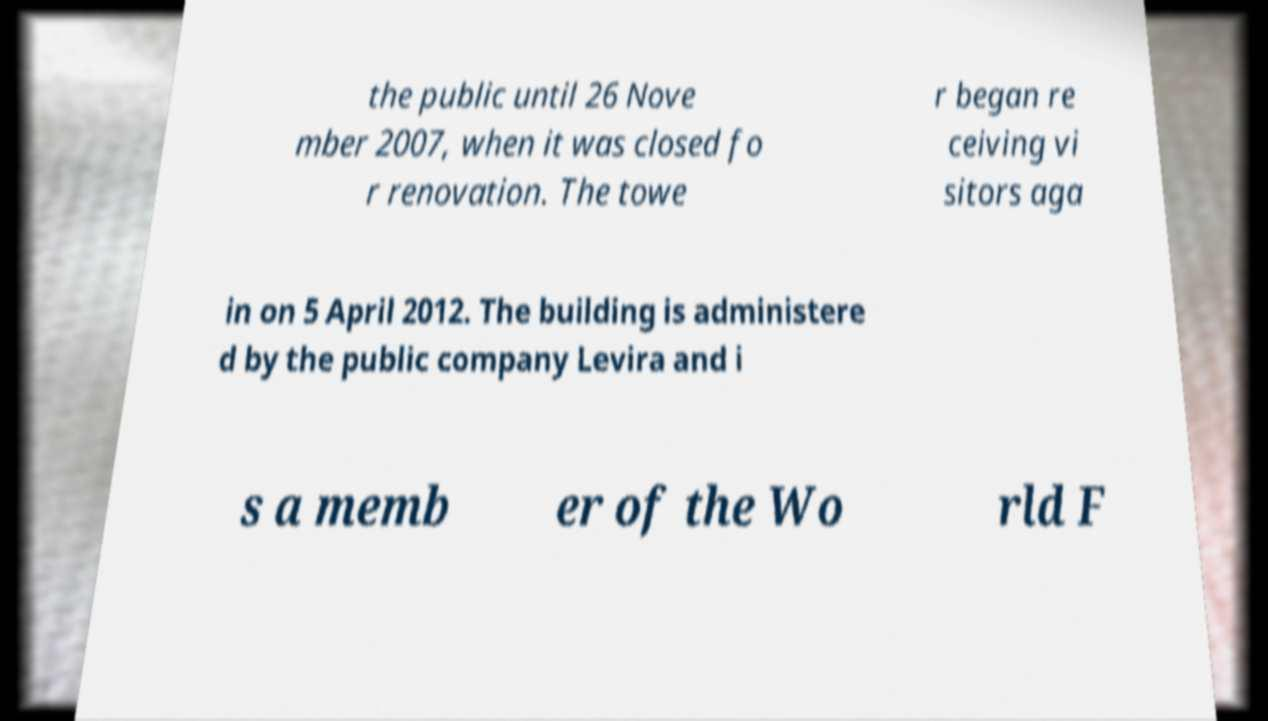There's text embedded in this image that I need extracted. Can you transcribe it verbatim? the public until 26 Nove mber 2007, when it was closed fo r renovation. The towe r began re ceiving vi sitors aga in on 5 April 2012. The building is administere d by the public company Levira and i s a memb er of the Wo rld F 